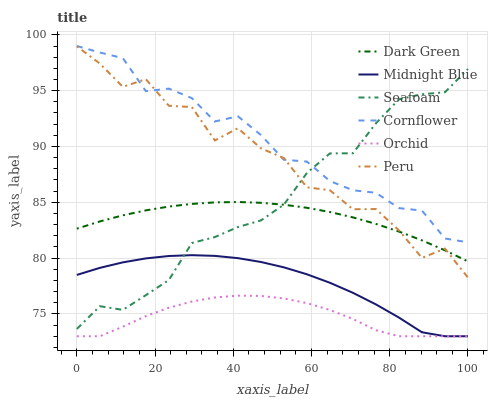Does Orchid have the minimum area under the curve?
Answer yes or no. Yes. Does Cornflower have the maximum area under the curve?
Answer yes or no. Yes. Does Midnight Blue have the minimum area under the curve?
Answer yes or no. No. Does Midnight Blue have the maximum area under the curve?
Answer yes or no. No. Is Dark Green the smoothest?
Answer yes or no. Yes. Is Peru the roughest?
Answer yes or no. Yes. Is Midnight Blue the smoothest?
Answer yes or no. No. Is Midnight Blue the roughest?
Answer yes or no. No. Does Seafoam have the lowest value?
Answer yes or no. No. Does Cornflower have the highest value?
Answer yes or no. Yes. Does Midnight Blue have the highest value?
Answer yes or no. No. Is Midnight Blue less than Cornflower?
Answer yes or no. Yes. Is Peru greater than Orchid?
Answer yes or no. Yes. Does Peru intersect Dark Green?
Answer yes or no. Yes. Is Peru less than Dark Green?
Answer yes or no. No. Is Peru greater than Dark Green?
Answer yes or no. No. Does Midnight Blue intersect Cornflower?
Answer yes or no. No. 